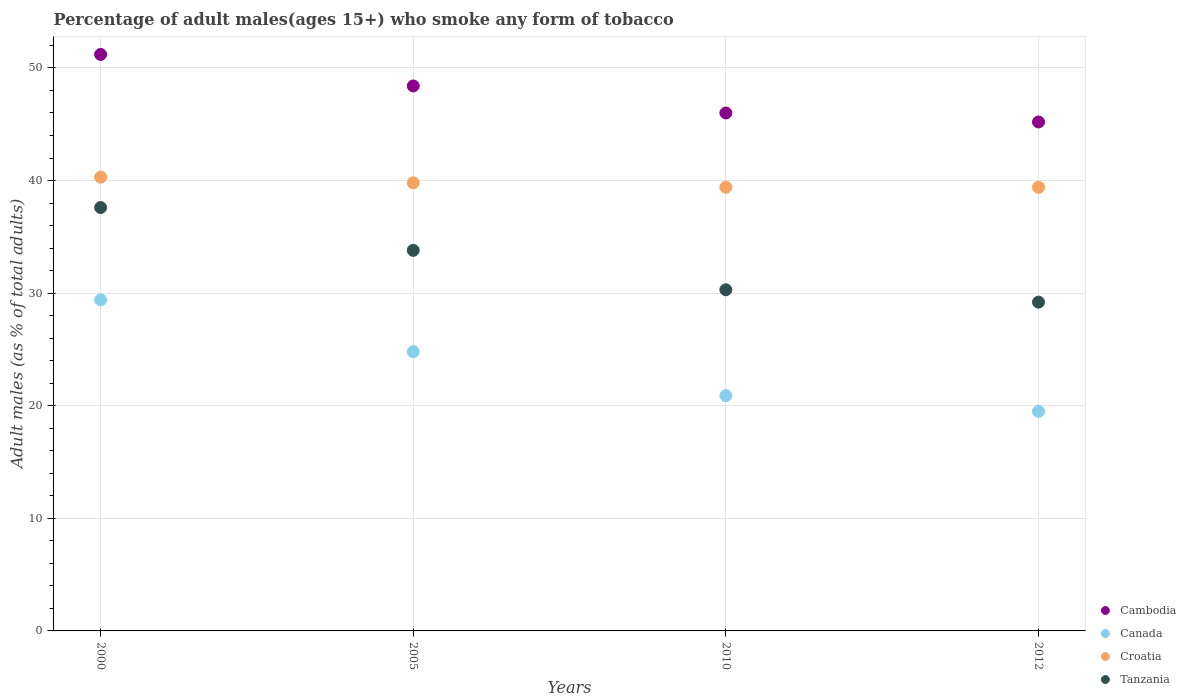What is the percentage of adult males who smoke in Croatia in 2000?
Your response must be concise. 40.3. Across all years, what is the maximum percentage of adult males who smoke in Canada?
Offer a very short reply. 29.4. Across all years, what is the minimum percentage of adult males who smoke in Canada?
Offer a terse response. 19.5. In which year was the percentage of adult males who smoke in Tanzania maximum?
Your response must be concise. 2000. In which year was the percentage of adult males who smoke in Canada minimum?
Make the answer very short. 2012. What is the total percentage of adult males who smoke in Tanzania in the graph?
Your answer should be compact. 130.9. What is the difference between the percentage of adult males who smoke in Cambodia in 2000 and the percentage of adult males who smoke in Tanzania in 2010?
Offer a very short reply. 20.9. What is the average percentage of adult males who smoke in Canada per year?
Give a very brief answer. 23.65. In the year 2010, what is the difference between the percentage of adult males who smoke in Tanzania and percentage of adult males who smoke in Cambodia?
Make the answer very short. -15.7. What is the ratio of the percentage of adult males who smoke in Tanzania in 2005 to that in 2012?
Provide a succinct answer. 1.16. What is the difference between the highest and the second highest percentage of adult males who smoke in Tanzania?
Offer a terse response. 3.8. What is the difference between the highest and the lowest percentage of adult males who smoke in Canada?
Keep it short and to the point. 9.9. In how many years, is the percentage of adult males who smoke in Cambodia greater than the average percentage of adult males who smoke in Cambodia taken over all years?
Ensure brevity in your answer.  2. Is the percentage of adult males who smoke in Cambodia strictly greater than the percentage of adult males who smoke in Canada over the years?
Make the answer very short. Yes. Is the percentage of adult males who smoke in Tanzania strictly less than the percentage of adult males who smoke in Cambodia over the years?
Offer a very short reply. Yes. How many dotlines are there?
Give a very brief answer. 4. How many years are there in the graph?
Provide a short and direct response. 4. Does the graph contain any zero values?
Provide a succinct answer. No. Where does the legend appear in the graph?
Make the answer very short. Bottom right. How are the legend labels stacked?
Your response must be concise. Vertical. What is the title of the graph?
Your answer should be very brief. Percentage of adult males(ages 15+) who smoke any form of tobacco. Does "Rwanda" appear as one of the legend labels in the graph?
Your answer should be very brief. No. What is the label or title of the X-axis?
Provide a succinct answer. Years. What is the label or title of the Y-axis?
Offer a terse response. Adult males (as % of total adults). What is the Adult males (as % of total adults) in Cambodia in 2000?
Make the answer very short. 51.2. What is the Adult males (as % of total adults) of Canada in 2000?
Ensure brevity in your answer.  29.4. What is the Adult males (as % of total adults) in Croatia in 2000?
Keep it short and to the point. 40.3. What is the Adult males (as % of total adults) in Tanzania in 2000?
Your answer should be compact. 37.6. What is the Adult males (as % of total adults) of Cambodia in 2005?
Ensure brevity in your answer.  48.4. What is the Adult males (as % of total adults) in Canada in 2005?
Your answer should be very brief. 24.8. What is the Adult males (as % of total adults) in Croatia in 2005?
Ensure brevity in your answer.  39.8. What is the Adult males (as % of total adults) of Tanzania in 2005?
Provide a short and direct response. 33.8. What is the Adult males (as % of total adults) of Cambodia in 2010?
Offer a very short reply. 46. What is the Adult males (as % of total adults) in Canada in 2010?
Make the answer very short. 20.9. What is the Adult males (as % of total adults) of Croatia in 2010?
Keep it short and to the point. 39.4. What is the Adult males (as % of total adults) of Tanzania in 2010?
Your response must be concise. 30.3. What is the Adult males (as % of total adults) of Cambodia in 2012?
Your answer should be very brief. 45.2. What is the Adult males (as % of total adults) of Croatia in 2012?
Give a very brief answer. 39.4. What is the Adult males (as % of total adults) of Tanzania in 2012?
Your answer should be very brief. 29.2. Across all years, what is the maximum Adult males (as % of total adults) of Cambodia?
Your response must be concise. 51.2. Across all years, what is the maximum Adult males (as % of total adults) of Canada?
Your answer should be compact. 29.4. Across all years, what is the maximum Adult males (as % of total adults) of Croatia?
Make the answer very short. 40.3. Across all years, what is the maximum Adult males (as % of total adults) in Tanzania?
Ensure brevity in your answer.  37.6. Across all years, what is the minimum Adult males (as % of total adults) of Cambodia?
Give a very brief answer. 45.2. Across all years, what is the minimum Adult males (as % of total adults) in Canada?
Provide a succinct answer. 19.5. Across all years, what is the minimum Adult males (as % of total adults) of Croatia?
Keep it short and to the point. 39.4. Across all years, what is the minimum Adult males (as % of total adults) of Tanzania?
Provide a succinct answer. 29.2. What is the total Adult males (as % of total adults) in Cambodia in the graph?
Give a very brief answer. 190.8. What is the total Adult males (as % of total adults) in Canada in the graph?
Your response must be concise. 94.6. What is the total Adult males (as % of total adults) of Croatia in the graph?
Keep it short and to the point. 158.9. What is the total Adult males (as % of total adults) in Tanzania in the graph?
Give a very brief answer. 130.9. What is the difference between the Adult males (as % of total adults) of Canada in 2000 and that in 2005?
Your response must be concise. 4.6. What is the difference between the Adult males (as % of total adults) of Croatia in 2000 and that in 2005?
Make the answer very short. 0.5. What is the difference between the Adult males (as % of total adults) in Tanzania in 2000 and that in 2005?
Provide a short and direct response. 3.8. What is the difference between the Adult males (as % of total adults) of Canada in 2000 and that in 2010?
Provide a short and direct response. 8.5. What is the difference between the Adult males (as % of total adults) in Cambodia in 2000 and that in 2012?
Make the answer very short. 6. What is the difference between the Adult males (as % of total adults) in Cambodia in 2005 and that in 2010?
Your answer should be very brief. 2.4. What is the difference between the Adult males (as % of total adults) in Canada in 2005 and that in 2010?
Your answer should be very brief. 3.9. What is the difference between the Adult males (as % of total adults) in Croatia in 2005 and that in 2010?
Your answer should be compact. 0.4. What is the difference between the Adult males (as % of total adults) in Tanzania in 2005 and that in 2010?
Ensure brevity in your answer.  3.5. What is the difference between the Adult males (as % of total adults) of Canada in 2005 and that in 2012?
Provide a succinct answer. 5.3. What is the difference between the Adult males (as % of total adults) of Tanzania in 2005 and that in 2012?
Provide a succinct answer. 4.6. What is the difference between the Adult males (as % of total adults) of Canada in 2010 and that in 2012?
Your answer should be compact. 1.4. What is the difference between the Adult males (as % of total adults) in Croatia in 2010 and that in 2012?
Your answer should be compact. 0. What is the difference between the Adult males (as % of total adults) of Cambodia in 2000 and the Adult males (as % of total adults) of Canada in 2005?
Provide a succinct answer. 26.4. What is the difference between the Adult males (as % of total adults) of Cambodia in 2000 and the Adult males (as % of total adults) of Croatia in 2005?
Ensure brevity in your answer.  11.4. What is the difference between the Adult males (as % of total adults) in Cambodia in 2000 and the Adult males (as % of total adults) in Tanzania in 2005?
Give a very brief answer. 17.4. What is the difference between the Adult males (as % of total adults) in Canada in 2000 and the Adult males (as % of total adults) in Croatia in 2005?
Provide a succinct answer. -10.4. What is the difference between the Adult males (as % of total adults) of Canada in 2000 and the Adult males (as % of total adults) of Tanzania in 2005?
Offer a very short reply. -4.4. What is the difference between the Adult males (as % of total adults) in Croatia in 2000 and the Adult males (as % of total adults) in Tanzania in 2005?
Your answer should be very brief. 6.5. What is the difference between the Adult males (as % of total adults) in Cambodia in 2000 and the Adult males (as % of total adults) in Canada in 2010?
Provide a short and direct response. 30.3. What is the difference between the Adult males (as % of total adults) in Cambodia in 2000 and the Adult males (as % of total adults) in Tanzania in 2010?
Provide a succinct answer. 20.9. What is the difference between the Adult males (as % of total adults) in Canada in 2000 and the Adult males (as % of total adults) in Croatia in 2010?
Provide a short and direct response. -10. What is the difference between the Adult males (as % of total adults) of Cambodia in 2000 and the Adult males (as % of total adults) of Canada in 2012?
Give a very brief answer. 31.7. What is the difference between the Adult males (as % of total adults) in Canada in 2000 and the Adult males (as % of total adults) in Croatia in 2012?
Your response must be concise. -10. What is the difference between the Adult males (as % of total adults) in Croatia in 2000 and the Adult males (as % of total adults) in Tanzania in 2012?
Offer a very short reply. 11.1. What is the difference between the Adult males (as % of total adults) of Cambodia in 2005 and the Adult males (as % of total adults) of Canada in 2010?
Ensure brevity in your answer.  27.5. What is the difference between the Adult males (as % of total adults) in Cambodia in 2005 and the Adult males (as % of total adults) in Croatia in 2010?
Provide a short and direct response. 9. What is the difference between the Adult males (as % of total adults) in Canada in 2005 and the Adult males (as % of total adults) in Croatia in 2010?
Provide a succinct answer. -14.6. What is the difference between the Adult males (as % of total adults) of Cambodia in 2005 and the Adult males (as % of total adults) of Canada in 2012?
Your answer should be compact. 28.9. What is the difference between the Adult males (as % of total adults) of Cambodia in 2005 and the Adult males (as % of total adults) of Croatia in 2012?
Provide a short and direct response. 9. What is the difference between the Adult males (as % of total adults) in Cambodia in 2005 and the Adult males (as % of total adults) in Tanzania in 2012?
Offer a terse response. 19.2. What is the difference between the Adult males (as % of total adults) of Canada in 2005 and the Adult males (as % of total adults) of Croatia in 2012?
Ensure brevity in your answer.  -14.6. What is the difference between the Adult males (as % of total adults) of Cambodia in 2010 and the Adult males (as % of total adults) of Canada in 2012?
Your answer should be very brief. 26.5. What is the difference between the Adult males (as % of total adults) in Cambodia in 2010 and the Adult males (as % of total adults) in Croatia in 2012?
Your answer should be compact. 6.6. What is the difference between the Adult males (as % of total adults) in Canada in 2010 and the Adult males (as % of total adults) in Croatia in 2012?
Your response must be concise. -18.5. What is the average Adult males (as % of total adults) of Cambodia per year?
Make the answer very short. 47.7. What is the average Adult males (as % of total adults) in Canada per year?
Provide a succinct answer. 23.65. What is the average Adult males (as % of total adults) of Croatia per year?
Give a very brief answer. 39.73. What is the average Adult males (as % of total adults) of Tanzania per year?
Offer a terse response. 32.73. In the year 2000, what is the difference between the Adult males (as % of total adults) of Cambodia and Adult males (as % of total adults) of Canada?
Your answer should be compact. 21.8. In the year 2000, what is the difference between the Adult males (as % of total adults) in Canada and Adult males (as % of total adults) in Croatia?
Your answer should be very brief. -10.9. In the year 2000, what is the difference between the Adult males (as % of total adults) in Croatia and Adult males (as % of total adults) in Tanzania?
Your response must be concise. 2.7. In the year 2005, what is the difference between the Adult males (as % of total adults) of Cambodia and Adult males (as % of total adults) of Canada?
Provide a succinct answer. 23.6. In the year 2005, what is the difference between the Adult males (as % of total adults) in Cambodia and Adult males (as % of total adults) in Tanzania?
Your response must be concise. 14.6. In the year 2005, what is the difference between the Adult males (as % of total adults) in Canada and Adult males (as % of total adults) in Croatia?
Ensure brevity in your answer.  -15. In the year 2005, what is the difference between the Adult males (as % of total adults) in Croatia and Adult males (as % of total adults) in Tanzania?
Ensure brevity in your answer.  6. In the year 2010, what is the difference between the Adult males (as % of total adults) in Cambodia and Adult males (as % of total adults) in Canada?
Provide a succinct answer. 25.1. In the year 2010, what is the difference between the Adult males (as % of total adults) in Canada and Adult males (as % of total adults) in Croatia?
Make the answer very short. -18.5. In the year 2012, what is the difference between the Adult males (as % of total adults) in Cambodia and Adult males (as % of total adults) in Canada?
Keep it short and to the point. 25.7. In the year 2012, what is the difference between the Adult males (as % of total adults) of Cambodia and Adult males (as % of total adults) of Tanzania?
Provide a succinct answer. 16. In the year 2012, what is the difference between the Adult males (as % of total adults) in Canada and Adult males (as % of total adults) in Croatia?
Provide a succinct answer. -19.9. What is the ratio of the Adult males (as % of total adults) in Cambodia in 2000 to that in 2005?
Your answer should be compact. 1.06. What is the ratio of the Adult males (as % of total adults) in Canada in 2000 to that in 2005?
Give a very brief answer. 1.19. What is the ratio of the Adult males (as % of total adults) in Croatia in 2000 to that in 2005?
Keep it short and to the point. 1.01. What is the ratio of the Adult males (as % of total adults) in Tanzania in 2000 to that in 2005?
Offer a very short reply. 1.11. What is the ratio of the Adult males (as % of total adults) in Cambodia in 2000 to that in 2010?
Offer a terse response. 1.11. What is the ratio of the Adult males (as % of total adults) in Canada in 2000 to that in 2010?
Your answer should be very brief. 1.41. What is the ratio of the Adult males (as % of total adults) of Croatia in 2000 to that in 2010?
Ensure brevity in your answer.  1.02. What is the ratio of the Adult males (as % of total adults) in Tanzania in 2000 to that in 2010?
Ensure brevity in your answer.  1.24. What is the ratio of the Adult males (as % of total adults) in Cambodia in 2000 to that in 2012?
Make the answer very short. 1.13. What is the ratio of the Adult males (as % of total adults) in Canada in 2000 to that in 2012?
Give a very brief answer. 1.51. What is the ratio of the Adult males (as % of total adults) of Croatia in 2000 to that in 2012?
Give a very brief answer. 1.02. What is the ratio of the Adult males (as % of total adults) in Tanzania in 2000 to that in 2012?
Offer a terse response. 1.29. What is the ratio of the Adult males (as % of total adults) in Cambodia in 2005 to that in 2010?
Give a very brief answer. 1.05. What is the ratio of the Adult males (as % of total adults) of Canada in 2005 to that in 2010?
Provide a succinct answer. 1.19. What is the ratio of the Adult males (as % of total adults) of Croatia in 2005 to that in 2010?
Your answer should be compact. 1.01. What is the ratio of the Adult males (as % of total adults) of Tanzania in 2005 to that in 2010?
Your response must be concise. 1.12. What is the ratio of the Adult males (as % of total adults) in Cambodia in 2005 to that in 2012?
Keep it short and to the point. 1.07. What is the ratio of the Adult males (as % of total adults) in Canada in 2005 to that in 2012?
Ensure brevity in your answer.  1.27. What is the ratio of the Adult males (as % of total adults) in Croatia in 2005 to that in 2012?
Provide a succinct answer. 1.01. What is the ratio of the Adult males (as % of total adults) in Tanzania in 2005 to that in 2012?
Make the answer very short. 1.16. What is the ratio of the Adult males (as % of total adults) of Cambodia in 2010 to that in 2012?
Offer a very short reply. 1.02. What is the ratio of the Adult males (as % of total adults) in Canada in 2010 to that in 2012?
Your answer should be compact. 1.07. What is the ratio of the Adult males (as % of total adults) in Croatia in 2010 to that in 2012?
Keep it short and to the point. 1. What is the ratio of the Adult males (as % of total adults) of Tanzania in 2010 to that in 2012?
Provide a short and direct response. 1.04. What is the difference between the highest and the second highest Adult males (as % of total adults) in Cambodia?
Make the answer very short. 2.8. What is the difference between the highest and the second highest Adult males (as % of total adults) in Canada?
Offer a very short reply. 4.6. What is the difference between the highest and the second highest Adult males (as % of total adults) in Croatia?
Keep it short and to the point. 0.5. What is the difference between the highest and the second highest Adult males (as % of total adults) of Tanzania?
Give a very brief answer. 3.8. What is the difference between the highest and the lowest Adult males (as % of total adults) of Cambodia?
Your response must be concise. 6. What is the difference between the highest and the lowest Adult males (as % of total adults) of Canada?
Your answer should be very brief. 9.9. What is the difference between the highest and the lowest Adult males (as % of total adults) in Croatia?
Your answer should be very brief. 0.9. 